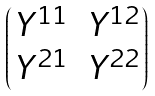<formula> <loc_0><loc_0><loc_500><loc_500>\begin{pmatrix} Y ^ { 1 1 } & Y ^ { 1 2 } \\ Y ^ { 2 1 } & Y ^ { 2 2 } \end{pmatrix}</formula> 